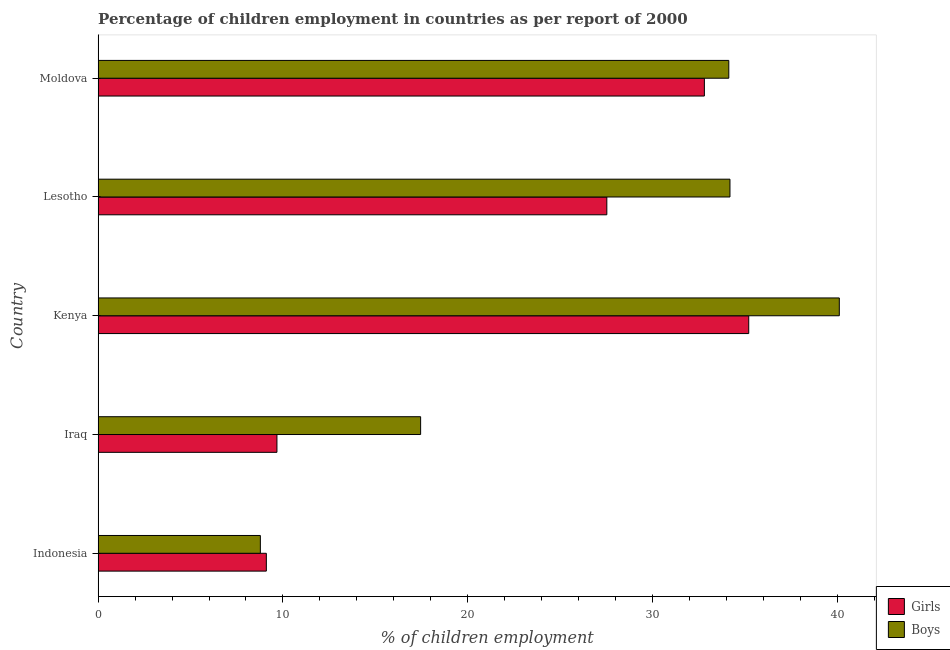How many groups of bars are there?
Your response must be concise. 5. How many bars are there on the 2nd tick from the bottom?
Your response must be concise. 2. What is the label of the 2nd group of bars from the top?
Keep it short and to the point. Lesotho. What is the percentage of employed girls in Kenya?
Provide a short and direct response. 35.2. Across all countries, what is the maximum percentage of employed boys?
Make the answer very short. 40.1. Across all countries, what is the minimum percentage of employed girls?
Make the answer very short. 9.1. In which country was the percentage of employed girls maximum?
Your answer should be compact. Kenya. What is the total percentage of employed boys in the graph?
Give a very brief answer. 134.63. What is the difference between the percentage of employed boys in Iraq and that in Moldova?
Offer a very short reply. -16.67. What is the difference between the percentage of employed girls in Moldova and the percentage of employed boys in Indonesia?
Your response must be concise. 24.02. What is the average percentage of employed girls per country?
Provide a short and direct response. 22.86. What is the difference between the percentage of employed boys and percentage of employed girls in Indonesia?
Offer a very short reply. -0.32. What is the ratio of the percentage of employed girls in Indonesia to that in Kenya?
Your answer should be very brief. 0.26. Is the percentage of employed girls in Indonesia less than that in Kenya?
Make the answer very short. Yes. Is the difference between the percentage of employed girls in Indonesia and Kenya greater than the difference between the percentage of employed boys in Indonesia and Kenya?
Your response must be concise. Yes. What is the difference between the highest and the lowest percentage of employed boys?
Keep it short and to the point. 31.32. In how many countries, is the percentage of employed girls greater than the average percentage of employed girls taken over all countries?
Provide a short and direct response. 3. Is the sum of the percentage of employed girls in Indonesia and Iraq greater than the maximum percentage of employed boys across all countries?
Your answer should be compact. No. What does the 1st bar from the top in Indonesia represents?
Offer a very short reply. Boys. What does the 2nd bar from the bottom in Iraq represents?
Ensure brevity in your answer.  Boys. How many countries are there in the graph?
Your answer should be very brief. 5. Does the graph contain any zero values?
Your response must be concise. No. Where does the legend appear in the graph?
Make the answer very short. Bottom right. How many legend labels are there?
Your answer should be compact. 2. What is the title of the graph?
Provide a succinct answer. Percentage of children employment in countries as per report of 2000. Does "Non-pregnant women" appear as one of the legend labels in the graph?
Give a very brief answer. No. What is the label or title of the X-axis?
Your response must be concise. % of children employment. What is the label or title of the Y-axis?
Offer a terse response. Country. What is the % of children employment of Girls in Indonesia?
Your answer should be very brief. 9.1. What is the % of children employment of Boys in Indonesia?
Your answer should be compact. 8.78. What is the % of children employment in Girls in Iraq?
Provide a short and direct response. 9.67. What is the % of children employment in Boys in Iraq?
Provide a succinct answer. 17.45. What is the % of children employment in Girls in Kenya?
Make the answer very short. 35.2. What is the % of children employment of Boys in Kenya?
Keep it short and to the point. 40.1. What is the % of children employment of Girls in Lesotho?
Keep it short and to the point. 27.52. What is the % of children employment in Boys in Lesotho?
Keep it short and to the point. 34.18. What is the % of children employment in Girls in Moldova?
Provide a succinct answer. 32.8. What is the % of children employment in Boys in Moldova?
Provide a short and direct response. 34.12. Across all countries, what is the maximum % of children employment in Girls?
Your answer should be very brief. 35.2. Across all countries, what is the maximum % of children employment of Boys?
Offer a very short reply. 40.1. Across all countries, what is the minimum % of children employment in Girls?
Provide a succinct answer. 9.1. Across all countries, what is the minimum % of children employment in Boys?
Ensure brevity in your answer.  8.78. What is the total % of children employment in Girls in the graph?
Your answer should be compact. 114.3. What is the total % of children employment in Boys in the graph?
Provide a succinct answer. 134.63. What is the difference between the % of children employment of Girls in Indonesia and that in Iraq?
Give a very brief answer. -0.57. What is the difference between the % of children employment of Boys in Indonesia and that in Iraq?
Your response must be concise. -8.67. What is the difference between the % of children employment of Girls in Indonesia and that in Kenya?
Your answer should be very brief. -26.1. What is the difference between the % of children employment of Boys in Indonesia and that in Kenya?
Provide a succinct answer. -31.32. What is the difference between the % of children employment in Girls in Indonesia and that in Lesotho?
Your answer should be compact. -18.42. What is the difference between the % of children employment of Boys in Indonesia and that in Lesotho?
Make the answer very short. -25.41. What is the difference between the % of children employment of Girls in Indonesia and that in Moldova?
Offer a terse response. -23.7. What is the difference between the % of children employment of Boys in Indonesia and that in Moldova?
Make the answer very short. -25.34. What is the difference between the % of children employment in Girls in Iraq and that in Kenya?
Offer a very short reply. -25.53. What is the difference between the % of children employment of Boys in Iraq and that in Kenya?
Provide a succinct answer. -22.65. What is the difference between the % of children employment of Girls in Iraq and that in Lesotho?
Give a very brief answer. -17.85. What is the difference between the % of children employment of Boys in Iraq and that in Lesotho?
Ensure brevity in your answer.  -16.74. What is the difference between the % of children employment in Girls in Iraq and that in Moldova?
Your answer should be compact. -23.13. What is the difference between the % of children employment in Boys in Iraq and that in Moldova?
Make the answer very short. -16.67. What is the difference between the % of children employment of Girls in Kenya and that in Lesotho?
Keep it short and to the point. 7.68. What is the difference between the % of children employment of Boys in Kenya and that in Lesotho?
Offer a terse response. 5.92. What is the difference between the % of children employment of Girls in Kenya and that in Moldova?
Provide a short and direct response. 2.4. What is the difference between the % of children employment in Boys in Kenya and that in Moldova?
Your answer should be very brief. 5.98. What is the difference between the % of children employment in Girls in Lesotho and that in Moldova?
Ensure brevity in your answer.  -5.28. What is the difference between the % of children employment of Boys in Lesotho and that in Moldova?
Keep it short and to the point. 0.06. What is the difference between the % of children employment in Girls in Indonesia and the % of children employment in Boys in Iraq?
Give a very brief answer. -8.35. What is the difference between the % of children employment in Girls in Indonesia and the % of children employment in Boys in Kenya?
Give a very brief answer. -31. What is the difference between the % of children employment of Girls in Indonesia and the % of children employment of Boys in Lesotho?
Provide a succinct answer. -25.08. What is the difference between the % of children employment in Girls in Indonesia and the % of children employment in Boys in Moldova?
Provide a short and direct response. -25.02. What is the difference between the % of children employment of Girls in Iraq and the % of children employment of Boys in Kenya?
Ensure brevity in your answer.  -30.43. What is the difference between the % of children employment in Girls in Iraq and the % of children employment in Boys in Lesotho?
Offer a very short reply. -24.51. What is the difference between the % of children employment of Girls in Iraq and the % of children employment of Boys in Moldova?
Your response must be concise. -24.45. What is the difference between the % of children employment of Girls in Kenya and the % of children employment of Boys in Lesotho?
Give a very brief answer. 1.02. What is the difference between the % of children employment of Girls in Kenya and the % of children employment of Boys in Moldova?
Make the answer very short. 1.08. What is the difference between the % of children employment in Girls in Lesotho and the % of children employment in Boys in Moldova?
Your response must be concise. -6.6. What is the average % of children employment of Girls per country?
Offer a very short reply. 22.86. What is the average % of children employment of Boys per country?
Make the answer very short. 26.93. What is the difference between the % of children employment in Girls and % of children employment in Boys in Indonesia?
Provide a short and direct response. 0.32. What is the difference between the % of children employment of Girls and % of children employment of Boys in Iraq?
Your answer should be compact. -7.77. What is the difference between the % of children employment in Girls and % of children employment in Boys in Lesotho?
Make the answer very short. -6.66. What is the difference between the % of children employment of Girls and % of children employment of Boys in Moldova?
Offer a terse response. -1.32. What is the ratio of the % of children employment of Girls in Indonesia to that in Iraq?
Give a very brief answer. 0.94. What is the ratio of the % of children employment of Boys in Indonesia to that in Iraq?
Provide a succinct answer. 0.5. What is the ratio of the % of children employment of Girls in Indonesia to that in Kenya?
Provide a succinct answer. 0.26. What is the ratio of the % of children employment in Boys in Indonesia to that in Kenya?
Offer a terse response. 0.22. What is the ratio of the % of children employment in Girls in Indonesia to that in Lesotho?
Make the answer very short. 0.33. What is the ratio of the % of children employment in Boys in Indonesia to that in Lesotho?
Offer a very short reply. 0.26. What is the ratio of the % of children employment of Girls in Indonesia to that in Moldova?
Give a very brief answer. 0.28. What is the ratio of the % of children employment in Boys in Indonesia to that in Moldova?
Make the answer very short. 0.26. What is the ratio of the % of children employment of Girls in Iraq to that in Kenya?
Your answer should be compact. 0.27. What is the ratio of the % of children employment of Boys in Iraq to that in Kenya?
Offer a very short reply. 0.44. What is the ratio of the % of children employment of Girls in Iraq to that in Lesotho?
Your answer should be compact. 0.35. What is the ratio of the % of children employment in Boys in Iraq to that in Lesotho?
Your response must be concise. 0.51. What is the ratio of the % of children employment of Girls in Iraq to that in Moldova?
Offer a terse response. 0.29. What is the ratio of the % of children employment of Boys in Iraq to that in Moldova?
Offer a terse response. 0.51. What is the ratio of the % of children employment of Girls in Kenya to that in Lesotho?
Give a very brief answer. 1.28. What is the ratio of the % of children employment in Boys in Kenya to that in Lesotho?
Give a very brief answer. 1.17. What is the ratio of the % of children employment of Girls in Kenya to that in Moldova?
Your answer should be very brief. 1.07. What is the ratio of the % of children employment of Boys in Kenya to that in Moldova?
Provide a succinct answer. 1.18. What is the ratio of the % of children employment of Girls in Lesotho to that in Moldova?
Offer a very short reply. 0.84. What is the difference between the highest and the second highest % of children employment of Boys?
Provide a succinct answer. 5.92. What is the difference between the highest and the lowest % of children employment of Girls?
Give a very brief answer. 26.1. What is the difference between the highest and the lowest % of children employment of Boys?
Offer a very short reply. 31.32. 